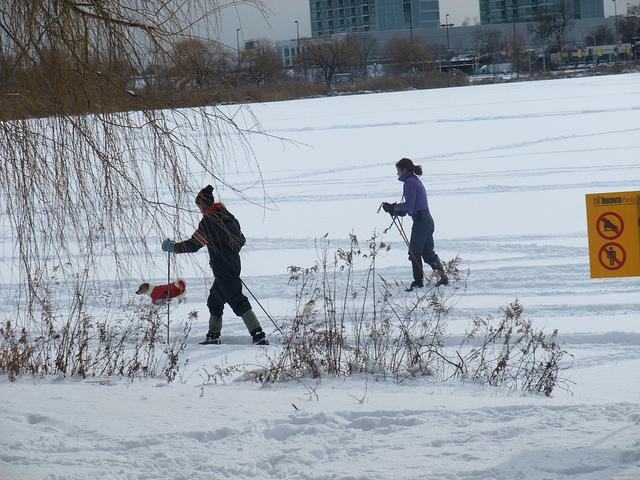What is the first activity that is not allowed on the ice?

Choices:
A) fishing
B) ice-skating
C) running
D) sledding ice-skating 